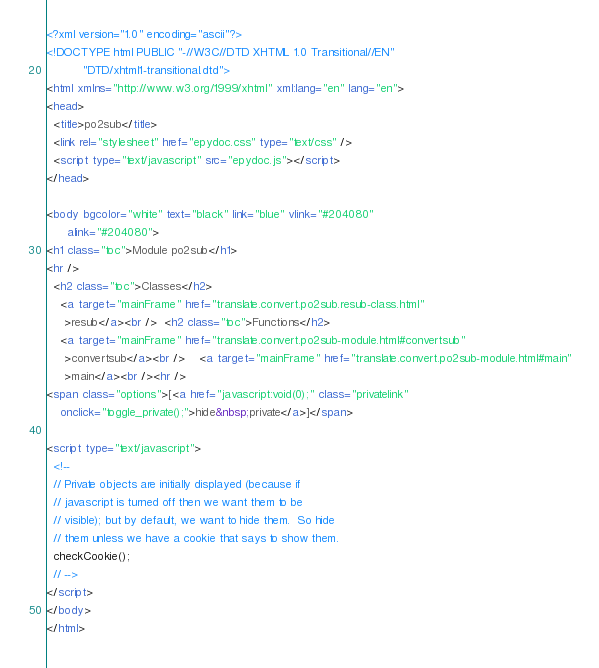<code> <loc_0><loc_0><loc_500><loc_500><_HTML_><?xml version="1.0" encoding="ascii"?>
<!DOCTYPE html PUBLIC "-//W3C//DTD XHTML 1.0 Transitional//EN"
          "DTD/xhtml1-transitional.dtd">
<html xmlns="http://www.w3.org/1999/xhtml" xml:lang="en" lang="en">
<head>
  <title>po2sub</title>
  <link rel="stylesheet" href="epydoc.css" type="text/css" />
  <script type="text/javascript" src="epydoc.js"></script>
</head>

<body bgcolor="white" text="black" link="blue" vlink="#204080"
      alink="#204080">
<h1 class="toc">Module po2sub</h1>
<hr />
  <h2 class="toc">Classes</h2>
    <a target="mainFrame" href="translate.convert.po2sub.resub-class.html"
     >resub</a><br />  <h2 class="toc">Functions</h2>
    <a target="mainFrame" href="translate.convert.po2sub-module.html#convertsub"
     >convertsub</a><br />    <a target="mainFrame" href="translate.convert.po2sub-module.html#main"
     >main</a><br /><hr />
<span class="options">[<a href="javascript:void(0);" class="privatelink"
    onclick="toggle_private();">hide&nbsp;private</a>]</span>

<script type="text/javascript">
  <!--
  // Private objects are initially displayed (because if
  // javascript is turned off then we want them to be
  // visible); but by default, we want to hide them.  So hide
  // them unless we have a cookie that says to show them.
  checkCookie();
  // -->
</script>
</body>
</html>
</code> 